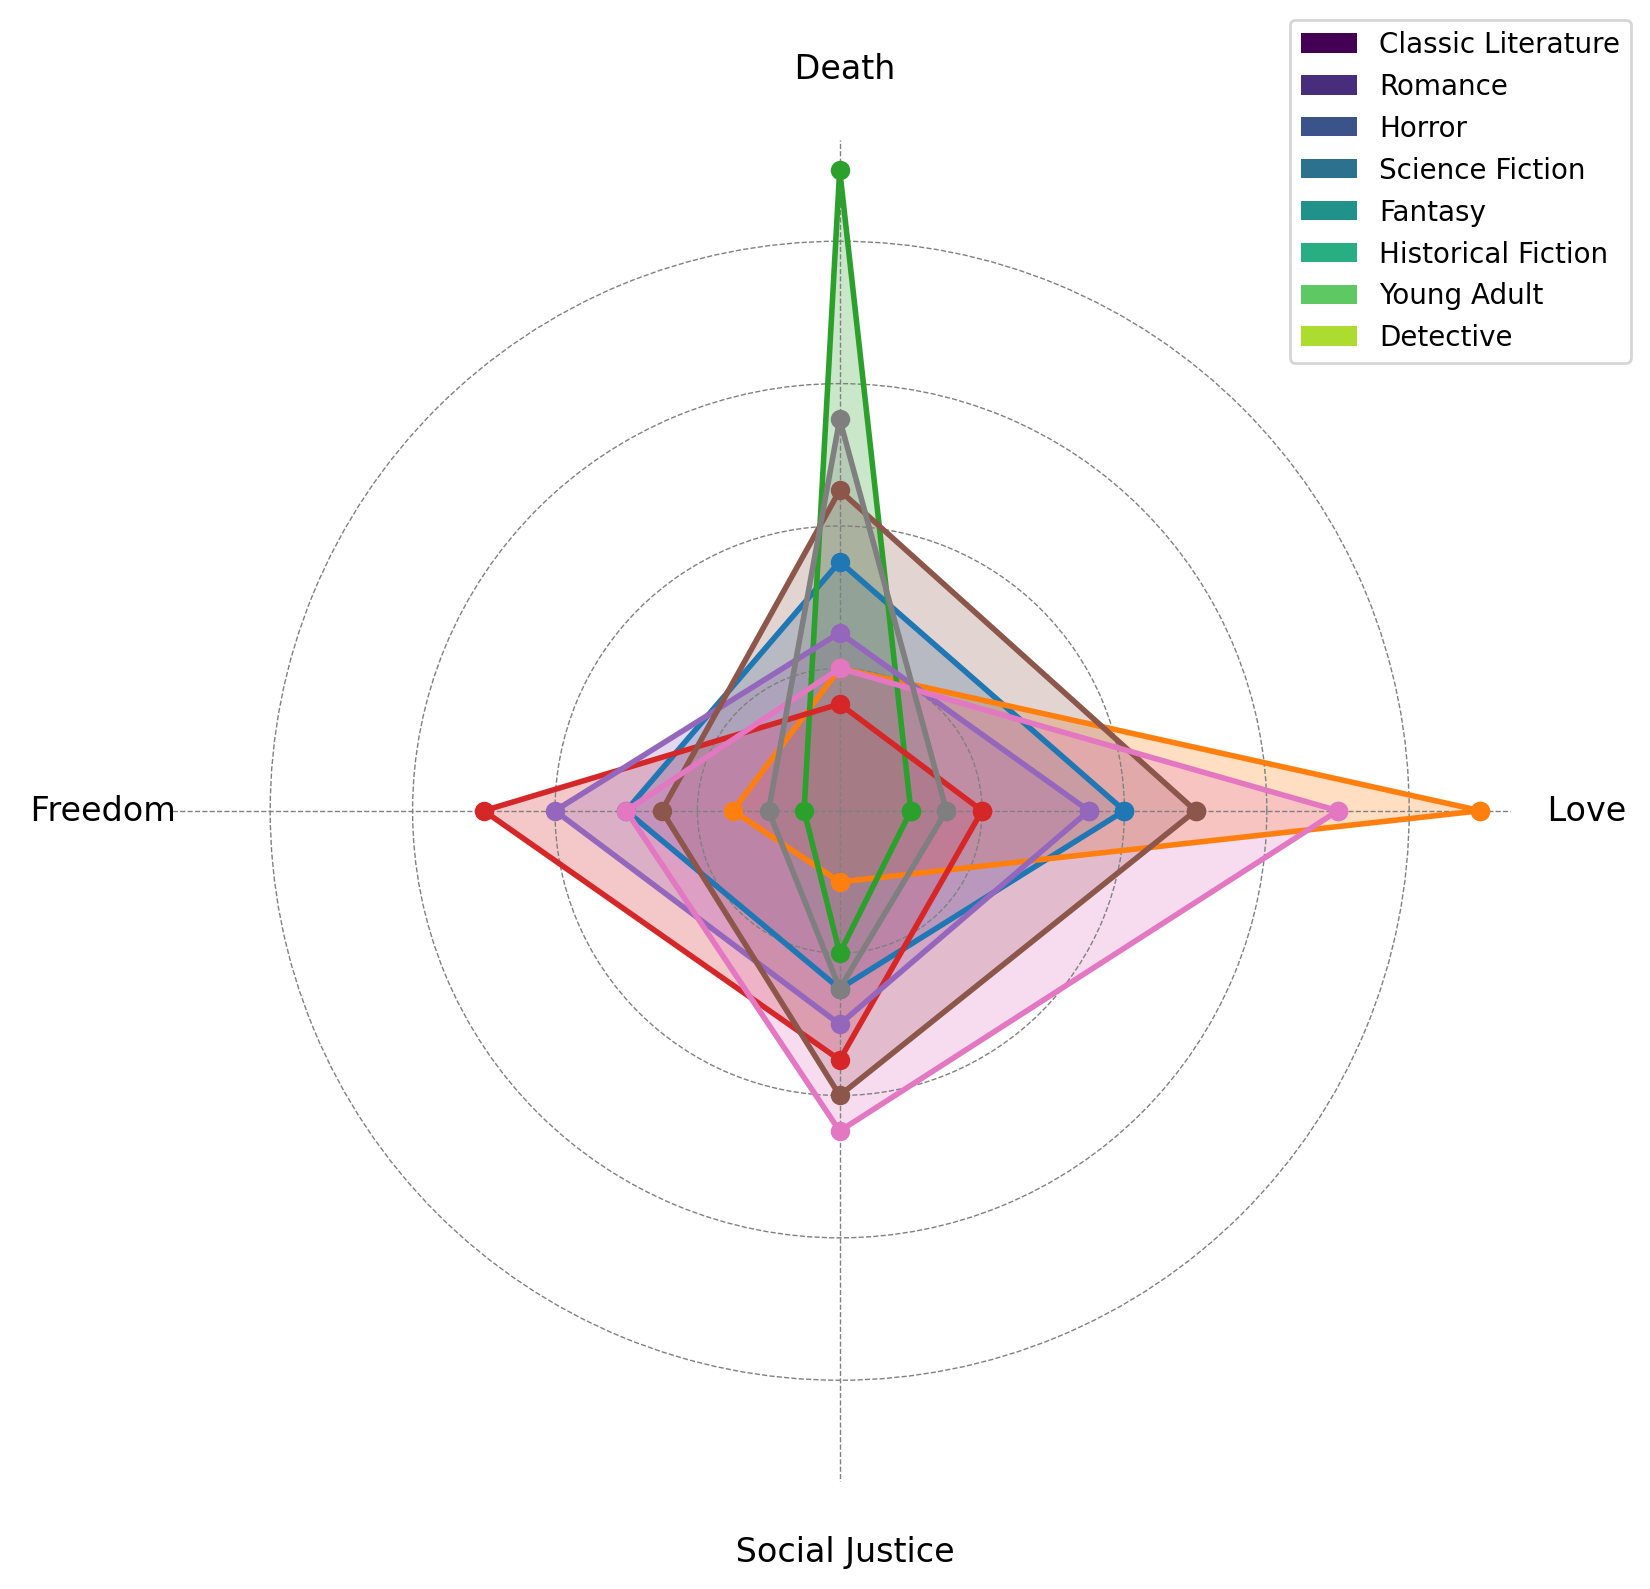What literary genre shows the highest frequency of the theme 'Love'? In the radar chart, the 'Love' axis measures the frequency of the theme 'Love' across different genres. By visually inspecting which line extends the furthest from the center, we see that 'Romance' has the highest value at 90.
Answer: Romance Which two genres have the closest frequencies for the theme 'Freedom'? By looking at the radar chart, compare the lengths of lines for the 'Freedom' axis. Both 'Young Adult' and 'Classic Literature' genres show a frequency of 30 for 'Freedom'.
Answer: Young Adult and Classic Literature How does the frequency of 'Social Justice' in 'Historical Fiction' compare to that in 'Science Fiction'? Inspect the 'Social Justice' axis and compare the lengths of lines for 'Historical Fiction' and 'Science Fiction'. 'Historical Fiction' has a value of 40, while 'Science Fiction' has a value of 35, showing that 'Historical Fiction' has a slightly higher frequency.
Answer: Historical Fiction is slightly higher Which genre has the most balanced frequencies across all themes? By interpreting the radar chart, look for the genre whose plot forms the most circular shape, indicating balanced values. The genre 'Fantasy' has relatively balanced values across all themes, but 'Historical Fiction' is also quite balanced.
Answer: Fantasy or Historical Fiction What is the average frequency of 'Death' across all genres? Add the frequencies of 'Death' for all genres and divide by the number of genres. The values are 35, 20, 90, 15, 25, 45, 20, and 55. Sum = 305, and there are 8 genres. So, the average is 305/8.
Answer: 38.125 How much higher is the 'Love' frequency in 'Romance' compared to 'Science Fiction'? Check the 'Love' frequencies for 'Romance' (90) and 'Science Fiction' (20). Subtract the smaller value from the larger value. So, 90 - 20.
Answer: 70 Which theme is most prominent in 'Horror'? Look at the radar chart for the genre 'Horror' and see which axis has the highest value. The 'Death' theme is most prominent in 'Horror' with a frequency of 90.
Answer: Death What is the difference in the 'Social Justice' frequency between 'Young Adult' and 'Detective'? Locate the 'Social Justice' frequencies for 'Young Adult' (45) and 'Detective' (25) on the radar chart. Subtract the smaller value from the larger value. So, 45 - 25.
Answer: 20 In which theme do 'Classic Literature' and 'Fantasy' have equal frequencies? Review the radar chart to compare the frequencies of themes between 'Classic Literature' and 'Fantasy'. Both have equal frequencies of 25 for the 'Death' theme.
Answer: Death 